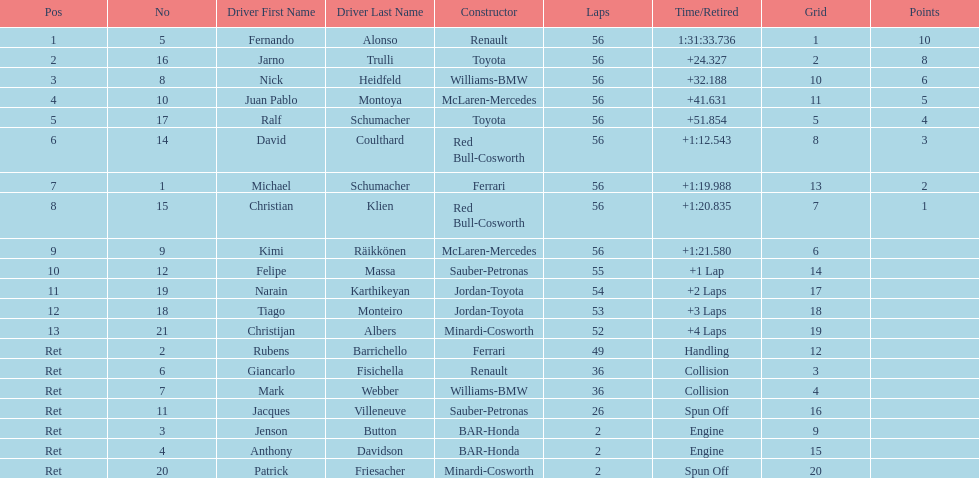Who was the last driver to actually finish the race? Christijan Albers. 